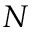<formula> <loc_0><loc_0><loc_500><loc_500>N</formula> 